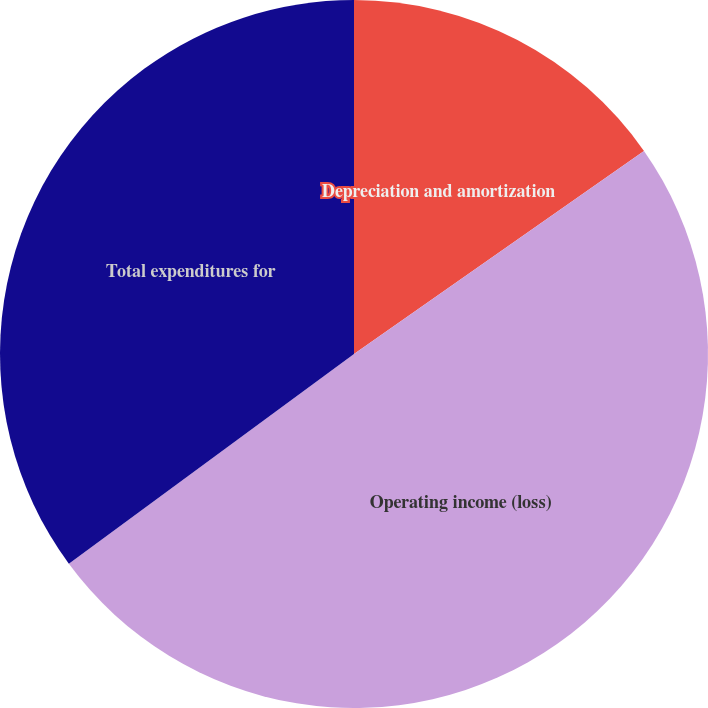<chart> <loc_0><loc_0><loc_500><loc_500><pie_chart><fcel>Depreciation and amortization<fcel>Operating income (loss)<fcel>Total expenditures for<nl><fcel>15.28%<fcel>49.63%<fcel>35.1%<nl></chart> 